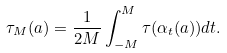<formula> <loc_0><loc_0><loc_500><loc_500>\tau _ { M } ( a ) = \frac { 1 } { 2 M } \int _ { - M } ^ { M } \tau ( \alpha _ { t } ( a ) ) d t .</formula> 